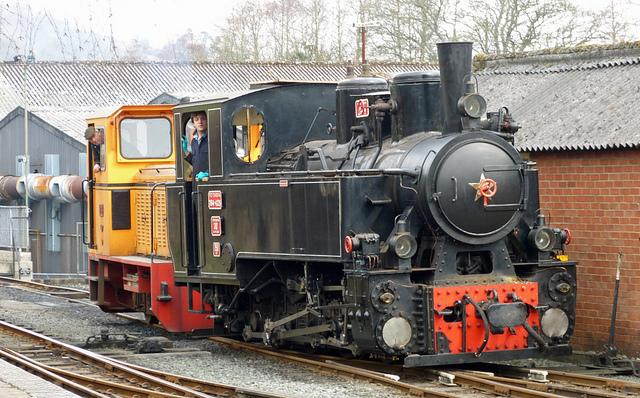Where were the first bricks used? Please explain your reasoning. middle east. The bricks are in the middle east. 